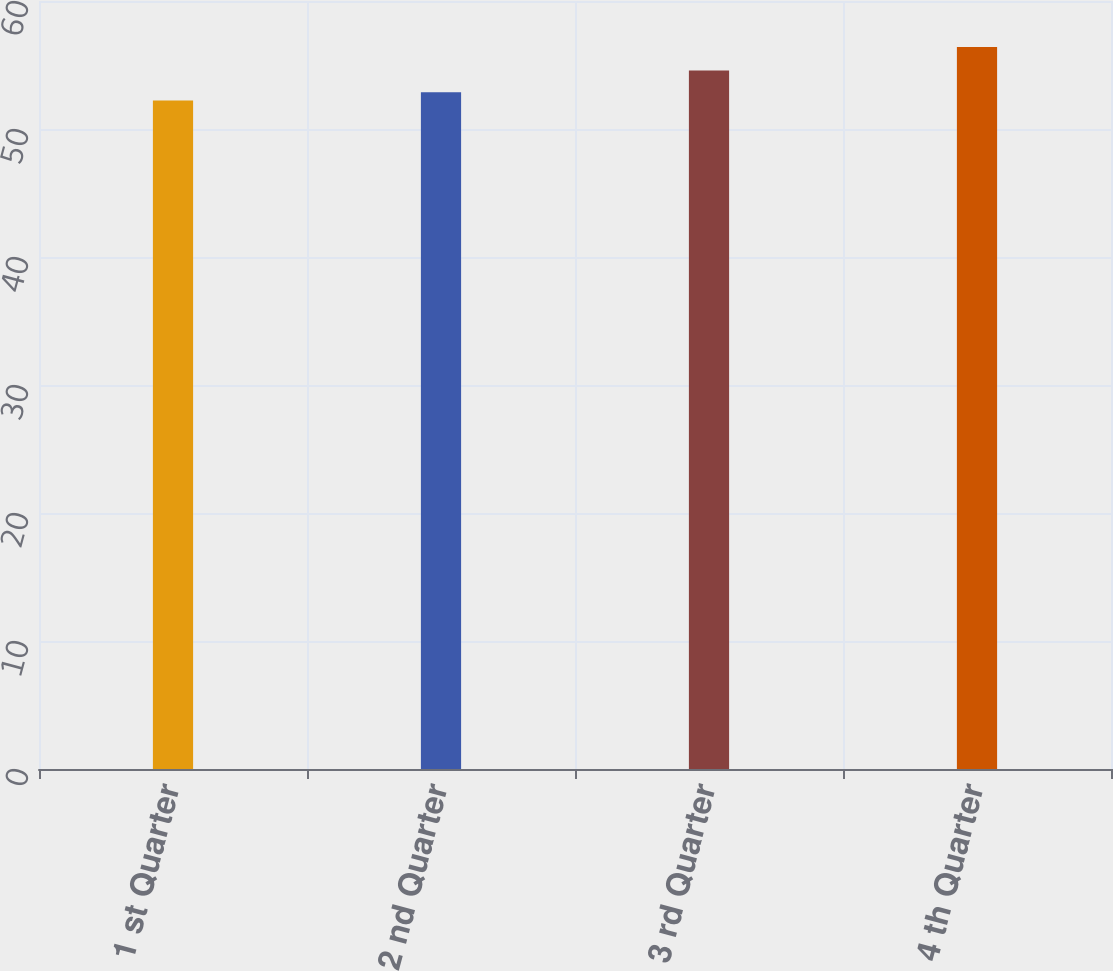Convert chart to OTSL. <chart><loc_0><loc_0><loc_500><loc_500><bar_chart><fcel>1 st Quarter<fcel>2 nd Quarter<fcel>3 rd Quarter<fcel>4 th Quarter<nl><fcel>52.23<fcel>52.87<fcel>54.58<fcel>56.4<nl></chart> 